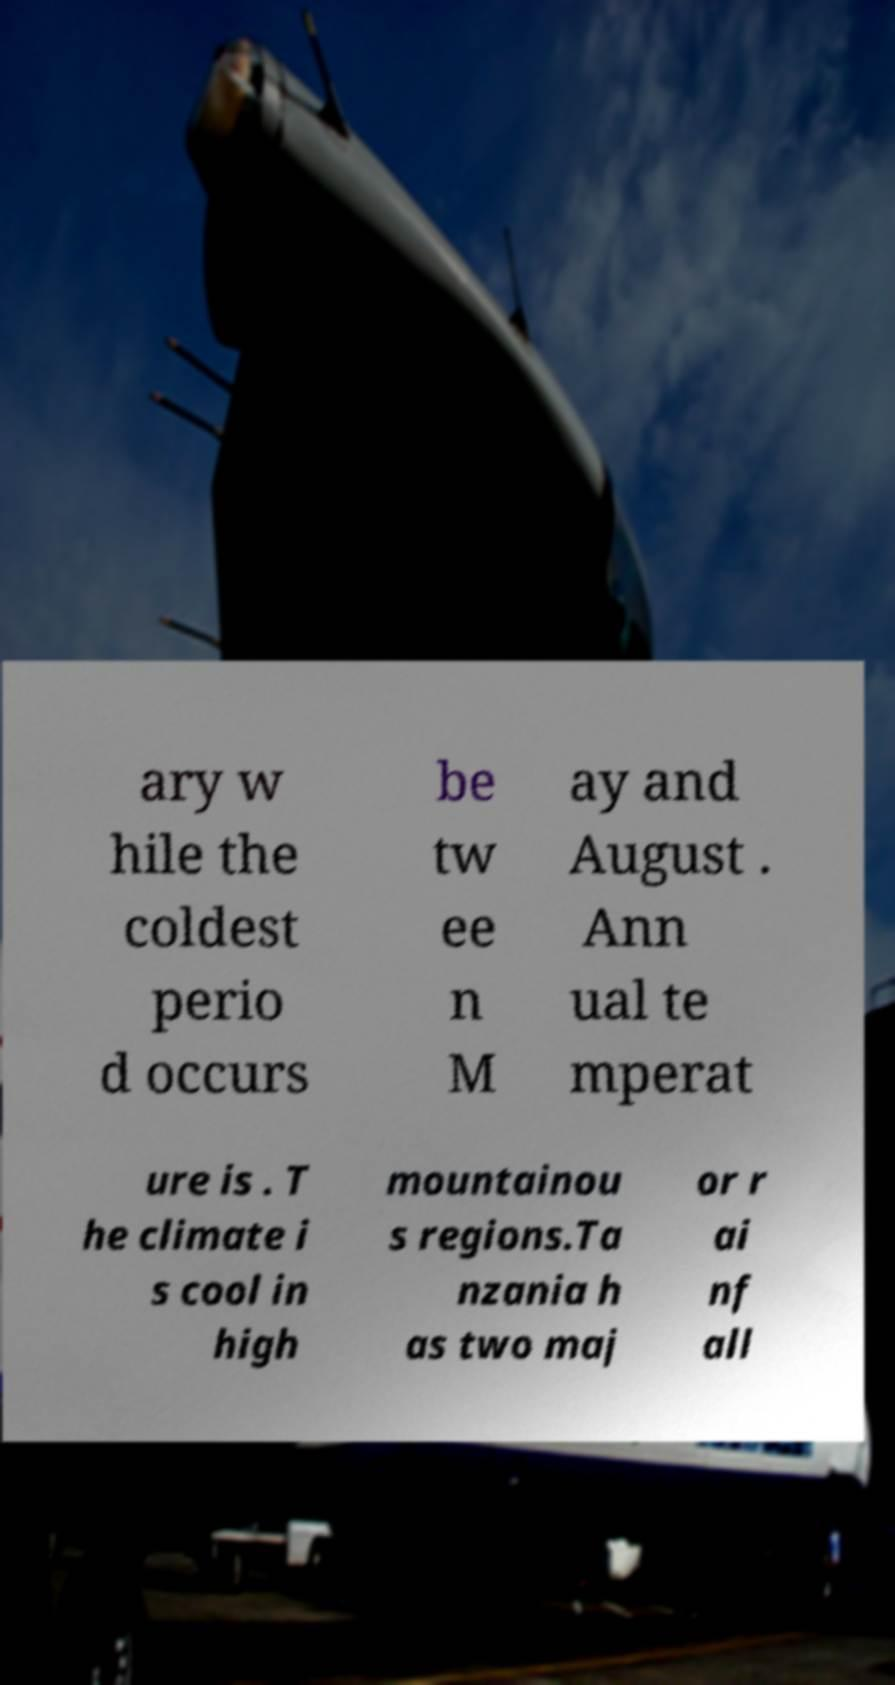Can you read and provide the text displayed in the image?This photo seems to have some interesting text. Can you extract and type it out for me? ary w hile the coldest perio d occurs be tw ee n M ay and August . Ann ual te mperat ure is . T he climate i s cool in high mountainou s regions.Ta nzania h as two maj or r ai nf all 